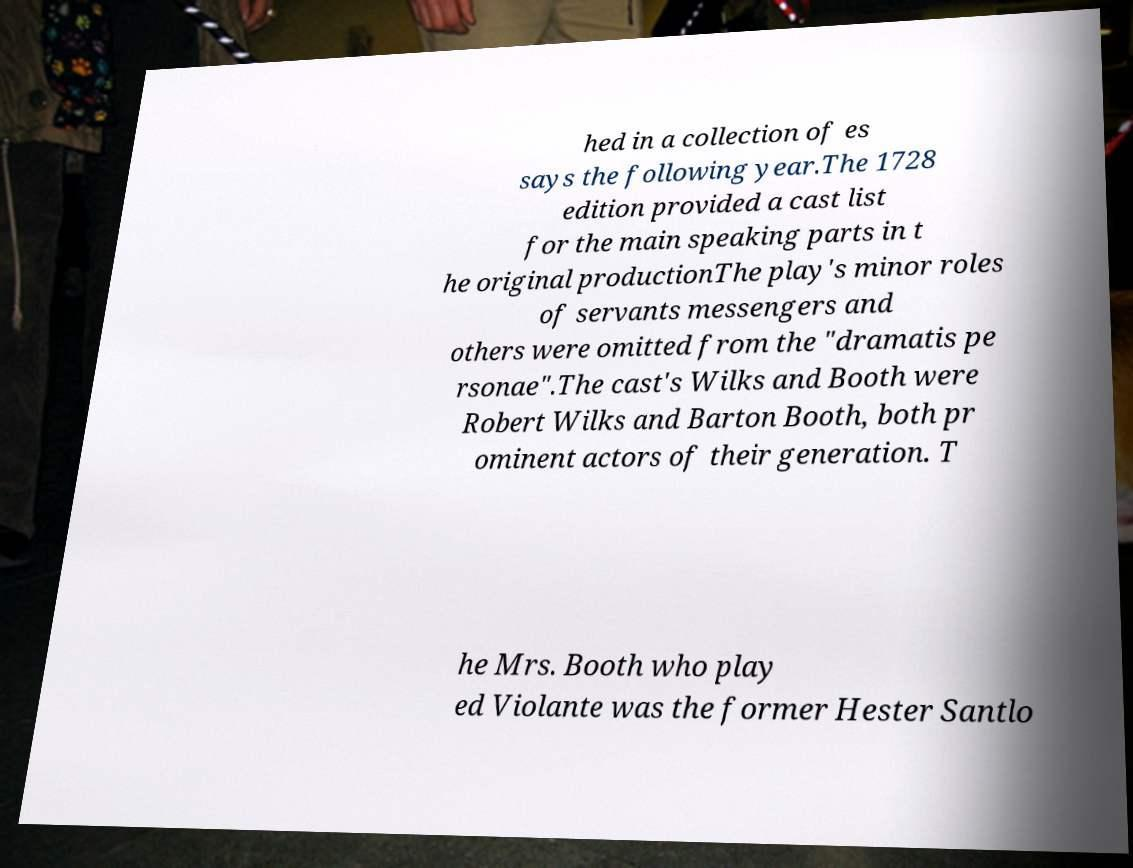Could you extract and type out the text from this image? hed in a collection of es says the following year.The 1728 edition provided a cast list for the main speaking parts in t he original productionThe play's minor roles of servants messengers and others were omitted from the "dramatis pe rsonae".The cast's Wilks and Booth were Robert Wilks and Barton Booth, both pr ominent actors of their generation. T he Mrs. Booth who play ed Violante was the former Hester Santlo 